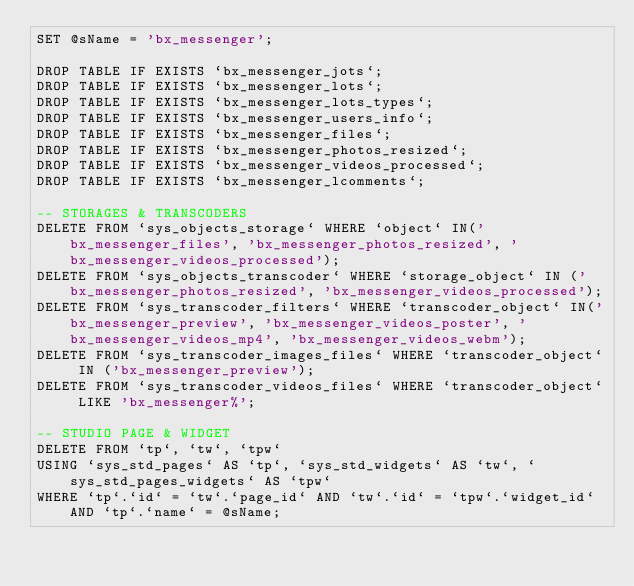<code> <loc_0><loc_0><loc_500><loc_500><_SQL_>SET @sName = 'bx_messenger';

DROP TABLE IF EXISTS `bx_messenger_jots`;
DROP TABLE IF EXISTS `bx_messenger_lots`;
DROP TABLE IF EXISTS `bx_messenger_lots_types`;
DROP TABLE IF EXISTS `bx_messenger_users_info`;
DROP TABLE IF EXISTS `bx_messenger_files`;
DROP TABLE IF EXISTS `bx_messenger_photos_resized`;
DROP TABLE IF EXISTS `bx_messenger_videos_processed`;
DROP TABLE IF EXISTS `bx_messenger_lcomments`;

-- STORAGES & TRANSCODERS
DELETE FROM `sys_objects_storage` WHERE `object` IN('bx_messenger_files', 'bx_messenger_photos_resized', 'bx_messenger_videos_processed');
DELETE FROM `sys_objects_transcoder` WHERE `storage_object` IN ('bx_messenger_photos_resized', 'bx_messenger_videos_processed');
DELETE FROM `sys_transcoder_filters` WHERE `transcoder_object` IN('bx_messenger_preview', 'bx_messenger_videos_poster', 'bx_messenger_videos_mp4', 'bx_messenger_videos_webm');
DELETE FROM `sys_transcoder_images_files` WHERE `transcoder_object` IN ('bx_messenger_preview');
DELETE FROM `sys_transcoder_videos_files` WHERE `transcoder_object` LIKE 'bx_messenger%';

-- STUDIO PAGE & WIDGET
DELETE FROM `tp`, `tw`, `tpw`
USING `sys_std_pages` AS `tp`, `sys_std_widgets` AS `tw`, `sys_std_pages_widgets` AS `tpw`
WHERE `tp`.`id` = `tw`.`page_id` AND `tw`.`id` = `tpw`.`widget_id` AND `tp`.`name` = @sName;</code> 